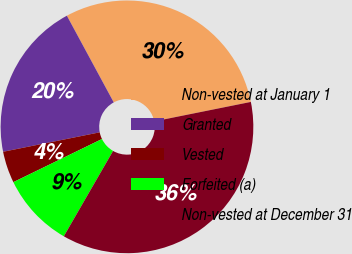<chart> <loc_0><loc_0><loc_500><loc_500><pie_chart><fcel>Non-vested at January 1<fcel>Granted<fcel>Vested<fcel>Forfeited (a)<fcel>Non-vested at December 31<nl><fcel>29.73%<fcel>20.27%<fcel>4.05%<fcel>9.46%<fcel>36.49%<nl></chart> 